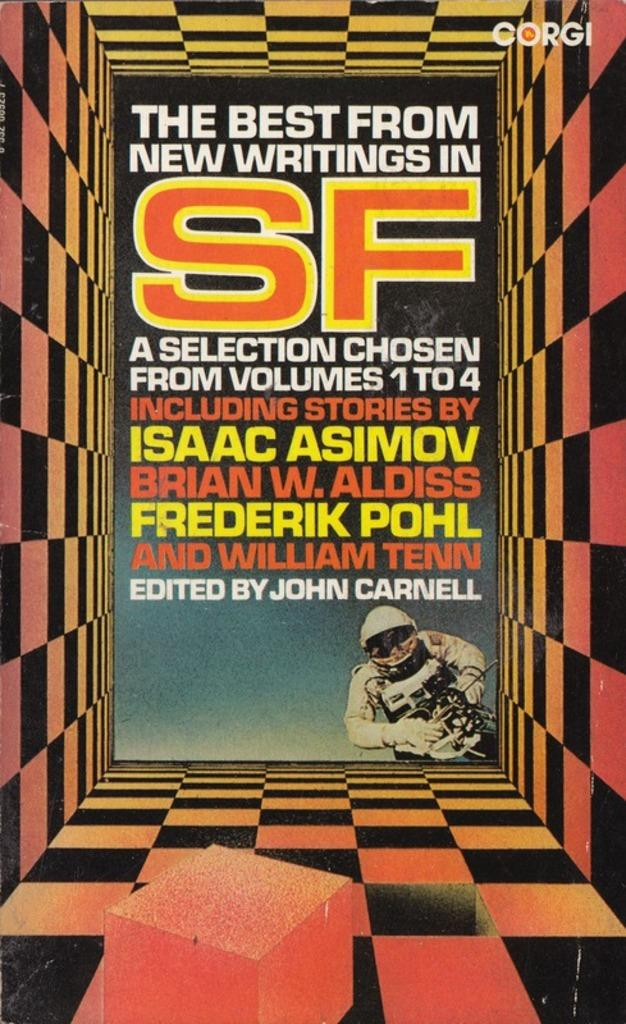<image>
Share a concise interpretation of the image provided. A book of new writings from science fiction including  Isaac Asimov. 